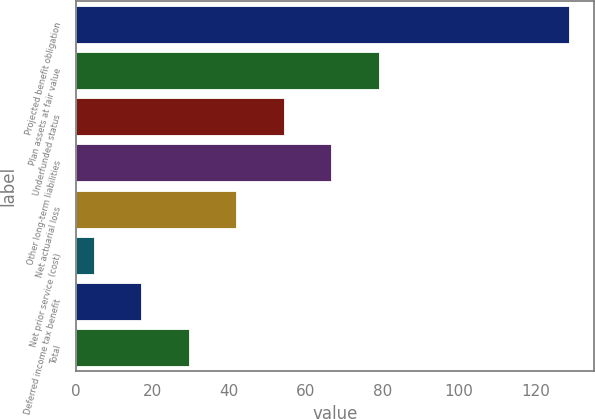Convert chart to OTSL. <chart><loc_0><loc_0><loc_500><loc_500><bar_chart><fcel>Projected benefit obligation<fcel>Plan assets at fair value<fcel>Underfunded status<fcel>Other long-term liabilities<fcel>Net actuarial loss<fcel>Net prior service (cost)<fcel>Deferred income tax benefit<fcel>Total<nl><fcel>128.7<fcel>79.06<fcel>54.24<fcel>66.65<fcel>41.83<fcel>4.6<fcel>17.01<fcel>29.42<nl></chart> 